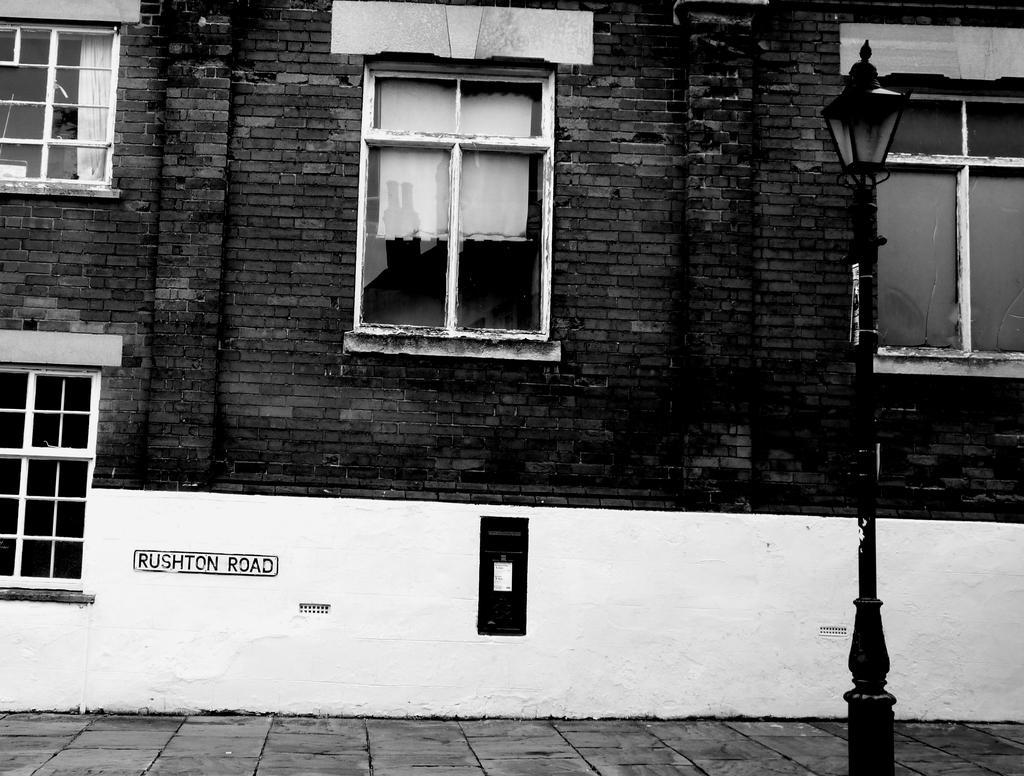Can you describe this image briefly? In this picture I can see the building. In the center there are windows. On the right there is a street light near to the white wall. On the white wall I can see some black object and name of the road. 